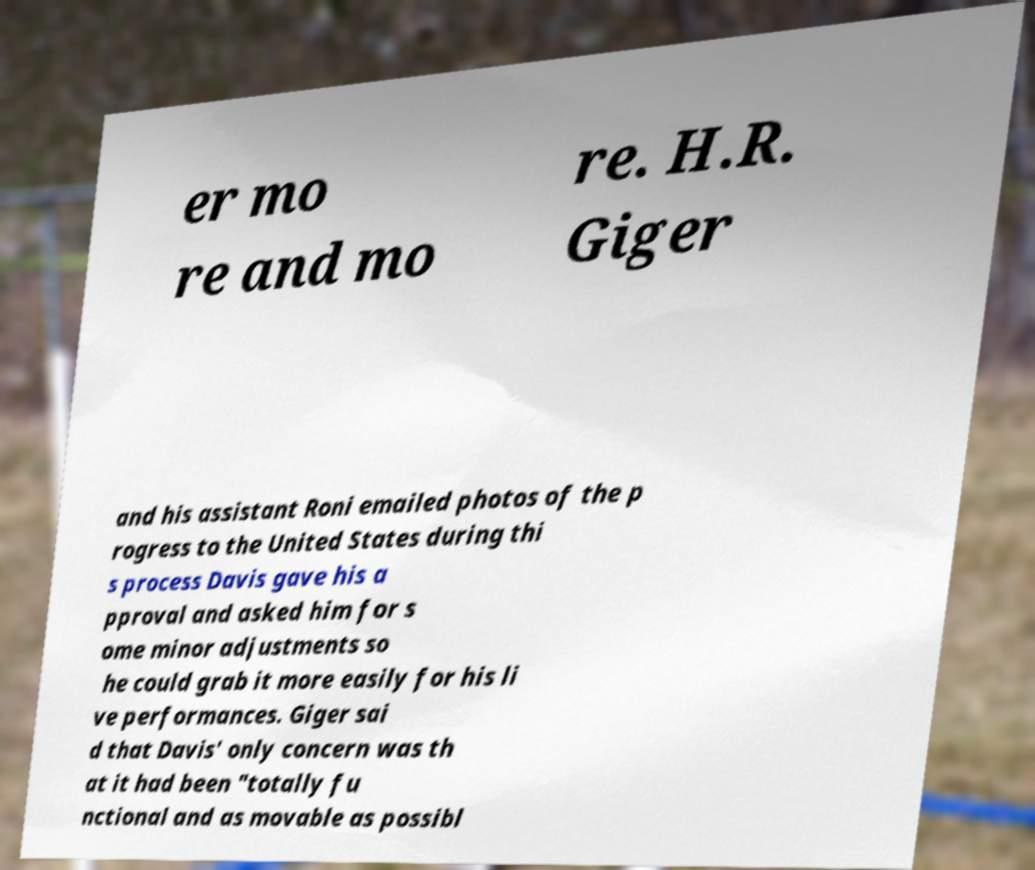What messages or text are displayed in this image? I need them in a readable, typed format. er mo re and mo re. H.R. Giger and his assistant Roni emailed photos of the p rogress to the United States during thi s process Davis gave his a pproval and asked him for s ome minor adjustments so he could grab it more easily for his li ve performances. Giger sai d that Davis' only concern was th at it had been "totally fu nctional and as movable as possibl 